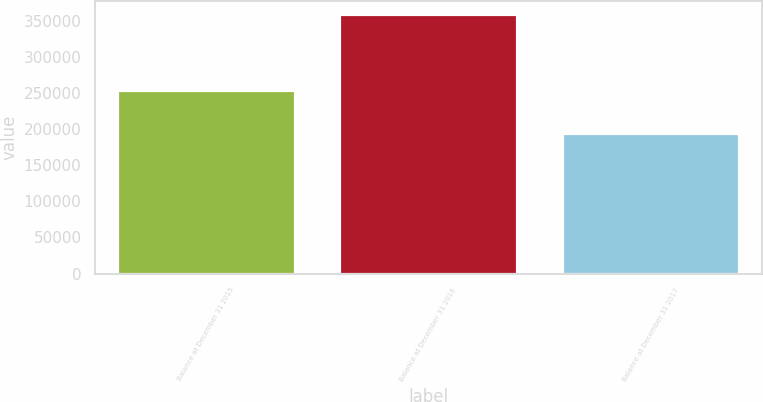<chart> <loc_0><loc_0><loc_500><loc_500><bar_chart><fcel>Balance at December 31 2015<fcel>Balance at December 31 2016<fcel>Balance at December 31 2017<nl><fcel>254573<fcel>359326<fcel>194759<nl></chart> 